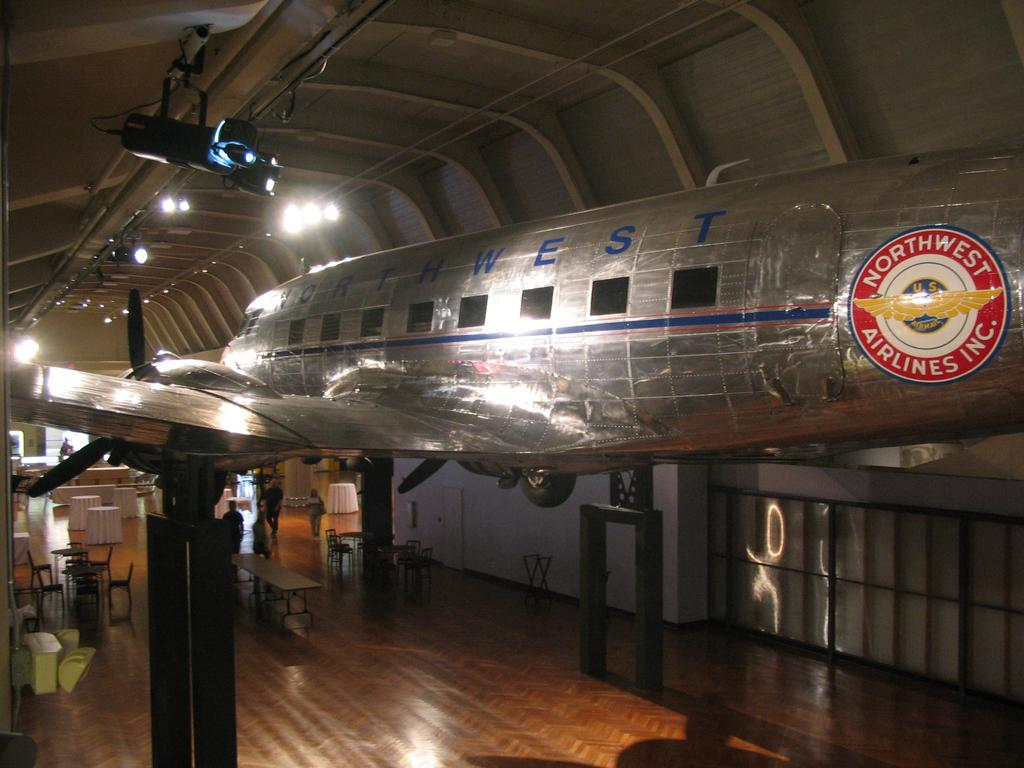Provide a one-sentence caption for the provided image. A silver airplane from Northwest Airlines is on display inside a building. 